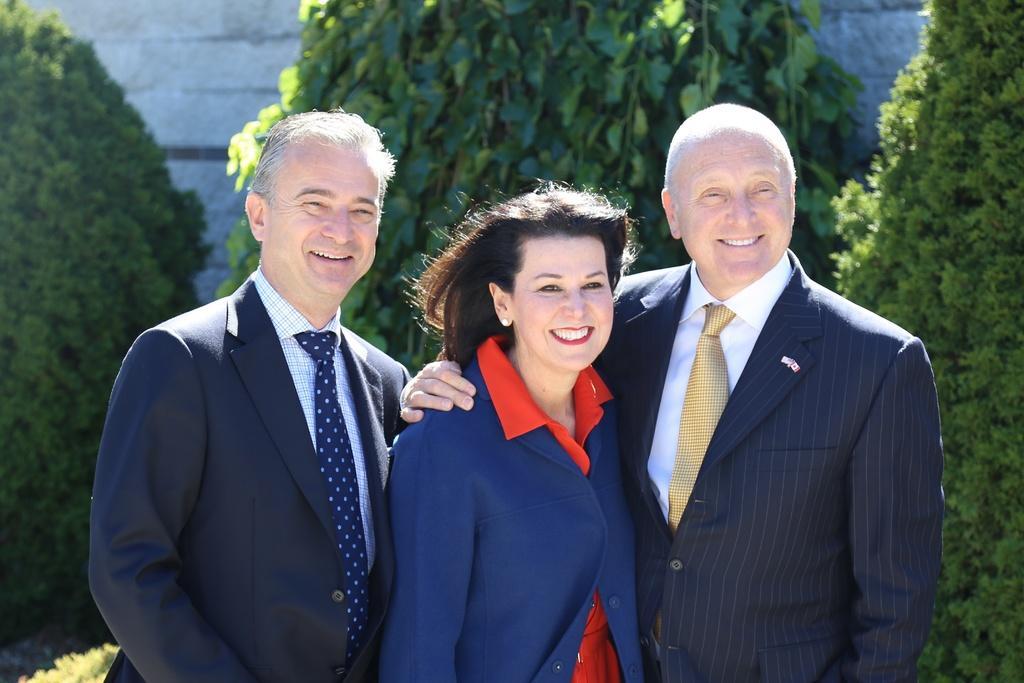Can you describe this image briefly? In this image we can see people standing. And we can see the trees and the wall. 